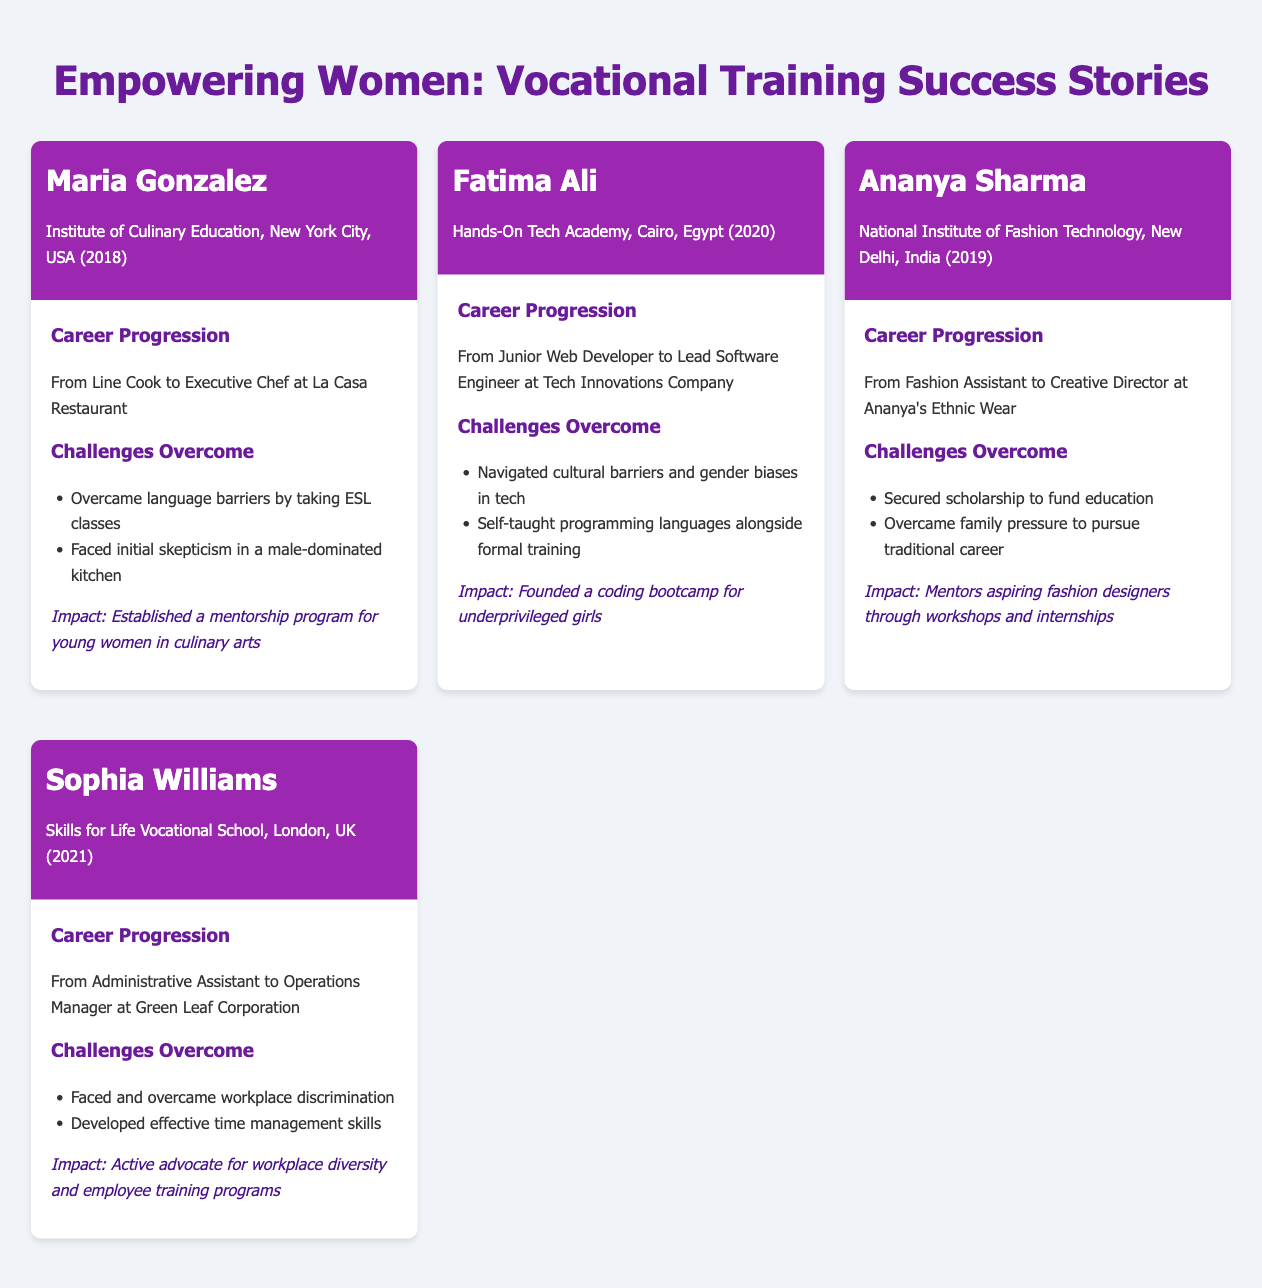What is the name of the first graduate featured? The first graduate featured in the document is Maria Gonzalez.
Answer: Maria Gonzalez What year did Fatima Ali graduate? The document states that Fatima Ali graduated in 2020.
Answer: 2020 What organization did Ananya Sharma attend? Ananya Sharma attended the National Institute of Fashion Technology.
Answer: National Institute of Fashion Technology What was Sophia Williams' initial job title? Sophia Williams started as an Administrative Assistant.
Answer: Administrative Assistant How many challenges did Maria Gonzalez overcome? The document lists two challenges that Maria Gonzalez overcame.
Answer: Two What type of program did Fatima Ali establish? Fatima Ali founded a coding bootcamp for underprivileged girls.
Answer: Coding bootcamp Which city is the Institute of Culinary Education located in? The Institute of Culinary Education is located in New York City.
Answer: New York City What is Ananya's Ethnic Wear's current role of Ananya Sharma? Ananya Sharma is the Creative Director at Ananya's Ethnic Wear.
Answer: Creative Director What impact did Sophia Williams have on workplace diversity? Sophia Williams is an active advocate for workplace diversity.
Answer: Advocate for workplace diversity 